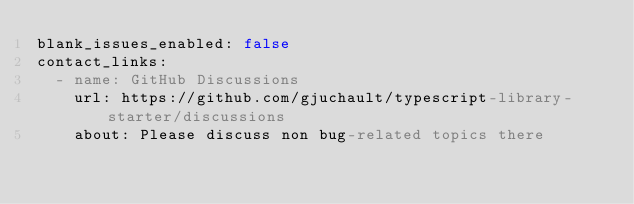Convert code to text. <code><loc_0><loc_0><loc_500><loc_500><_YAML_>blank_issues_enabled: false
contact_links:
  - name: GitHub Discussions
    url: https://github.com/gjuchault/typescript-library-starter/discussions
    about: Please discuss non bug-related topics there
</code> 